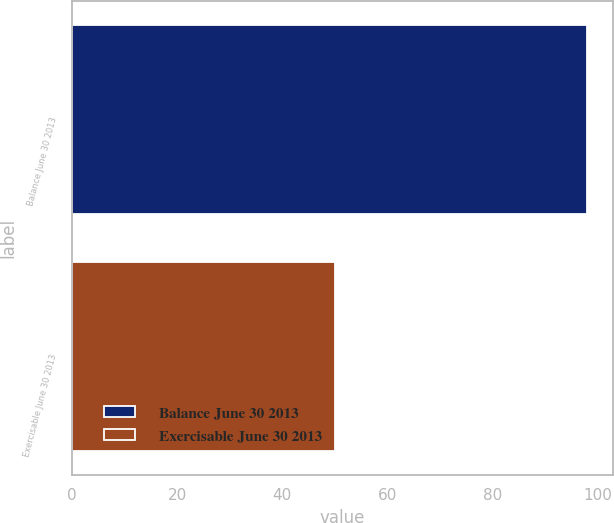Convert chart to OTSL. <chart><loc_0><loc_0><loc_500><loc_500><bar_chart><fcel>Balance June 30 2013<fcel>Exercisable June 30 2013<nl><fcel>98<fcel>50<nl></chart> 